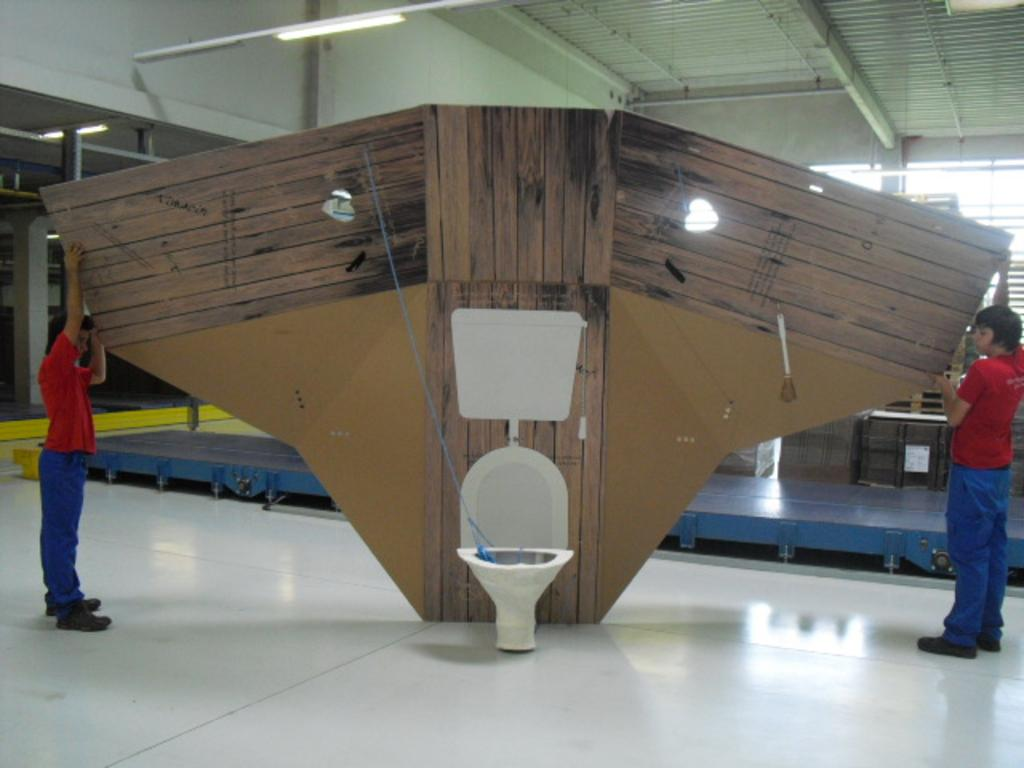How many people are in the image? There are two people in the image. Where is the first person located in the image? The first person is on the left side. Where is the second person located in the image? The second person is on the right side. What are the people holding in the image? Both people are holding big wooden planks. What type of yarn is the person on the left side using in the image? There is no yarn present in the image; both people are holding big wooden planks. 